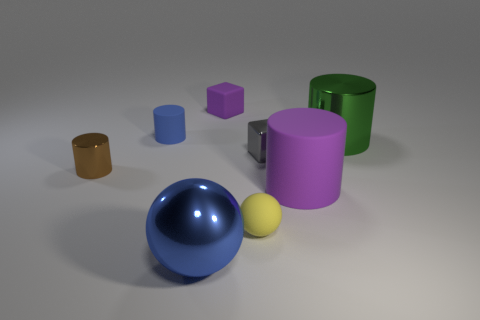Is there any other thing that has the same material as the gray cube?
Your response must be concise. Yes. Is the number of tiny rubber spheres behind the tiny brown cylinder greater than the number of purple cylinders in front of the large metal sphere?
Offer a terse response. No. There is a blue thing that is the same material as the large green thing; what is its shape?
Your response must be concise. Sphere. How many other things are there of the same shape as the blue shiny object?
Your answer should be very brief. 1. There is a metal thing that is in front of the small rubber sphere; what shape is it?
Make the answer very short. Sphere. The tiny metallic cylinder has what color?
Ensure brevity in your answer.  Brown. How many other objects are the same size as the brown thing?
Ensure brevity in your answer.  4. What material is the tiny block that is right of the cube that is behind the big green cylinder made of?
Ensure brevity in your answer.  Metal. Do the green metal cylinder and the matte thing that is on the right side of the yellow rubber sphere have the same size?
Your answer should be compact. Yes. Are there any matte cylinders that have the same color as the tiny rubber block?
Your answer should be compact. Yes. 